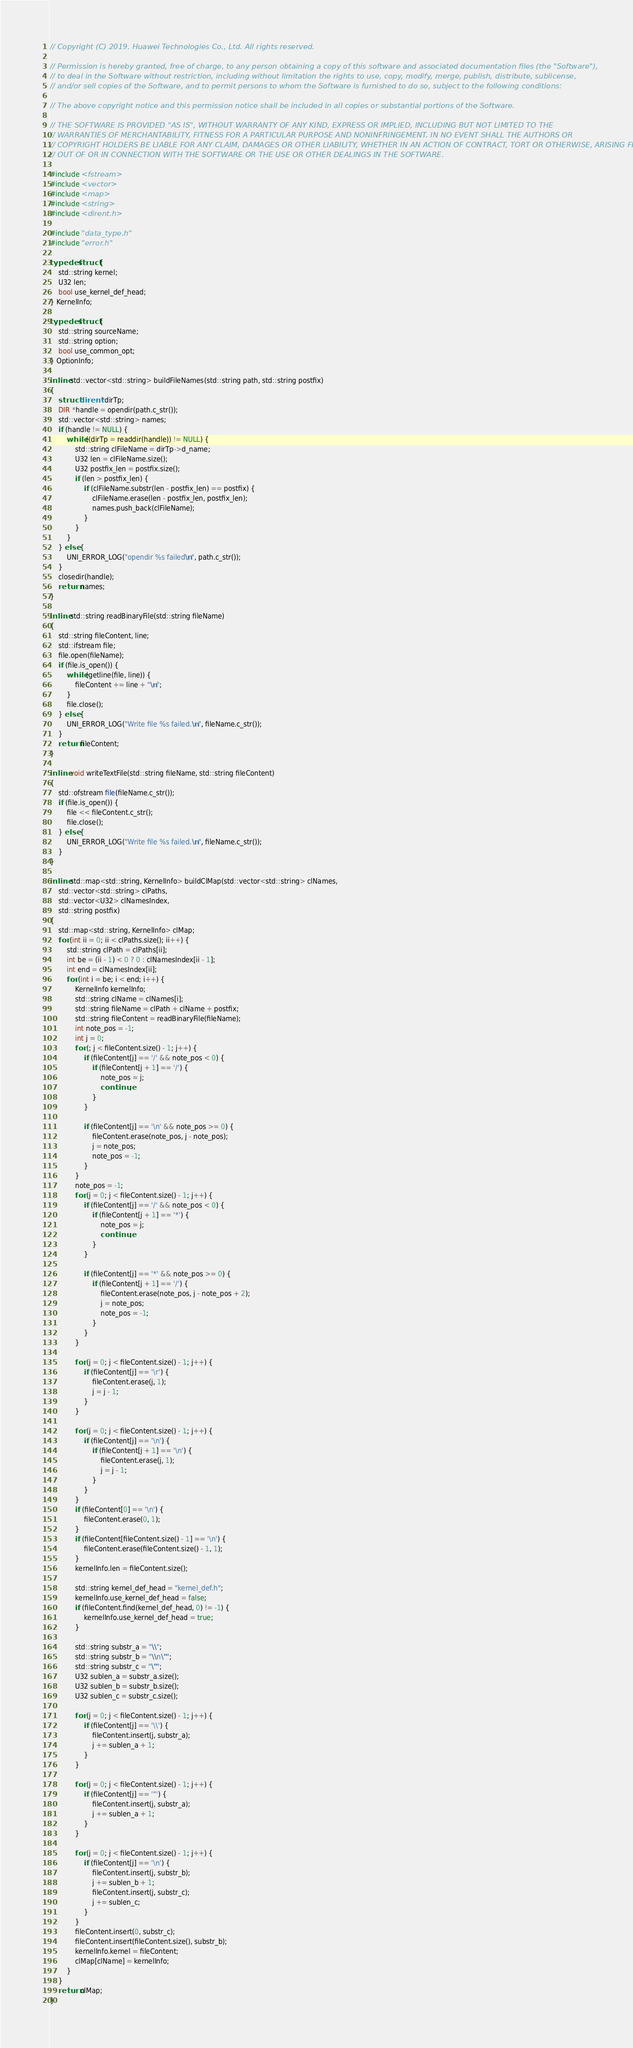<code> <loc_0><loc_0><loc_500><loc_500><_C++_>// Copyright (C) 2019. Huawei Technologies Co., Ltd. All rights reserved.

// Permission is hereby granted, free of charge, to any person obtaining a copy of this software and associated documentation files (the "Software"),
// to deal in the Software without restriction, including without limitation the rights to use, copy, modify, merge, publish, distribute, sublicense,
// and/or sell copies of the Software, and to permit persons to whom the Software is furnished to do so, subject to the following conditions:

// The above copyright notice and this permission notice shall be included in all copies or substantial portions of the Software.

// THE SOFTWARE IS PROVIDED "AS IS", WITHOUT WARRANTY OF ANY KIND, EXPRESS OR IMPLIED, INCLUDING BUT NOT LIMITED TO THE
// WARRANTIES OF MERCHANTABILITY, FITNESS FOR A PARTICULAR PURPOSE AND NONINFRINGEMENT. IN NO EVENT SHALL THE AUTHORS OR
// COPYRIGHT HOLDERS BE LIABLE FOR ANY CLAIM, DAMAGES OR OTHER LIABILITY, WHETHER IN AN ACTION OF CONTRACT, TORT OR OTHERWISE, ARISING FROM,
// OUT OF OR IN CONNECTION WITH THE SOFTWARE OR THE USE OR OTHER DEALINGS IN THE SOFTWARE.

#include <fstream>
#include <vector>
#include <map>
#include <string>
#include <dirent.h>

#include "data_type.h"
#include "error.h"

typedef struct {
    std::string kernel;
    U32 len;
    bool use_kernel_def_head;
} KernelInfo;

typedef struct {
    std::string sourceName;
    std::string option;
    bool use_common_opt;
} OptionInfo;

inline std::vector<std::string> buildFileNames(std::string path, std::string postfix)
{
    struct dirent *dirTp;
    DIR *handle = opendir(path.c_str());
    std::vector<std::string> names;
    if (handle != NULL) {
        while ((dirTp = readdir(handle)) != NULL) {
            std::string clFileName = dirTp->d_name;
            U32 len = clFileName.size();
            U32 postfix_len = postfix.size();
            if (len > postfix_len) {
                if (clFileName.substr(len - postfix_len) == postfix) {
                    clFileName.erase(len - postfix_len, postfix_len);
                    names.push_back(clFileName);
                }
            }
        }
    } else {
        UNI_ERROR_LOG("opendir %s failed\n", path.c_str());
    }
    closedir(handle);
    return names;
}

inline std::string readBinaryFile(std::string fileName)
{
    std::string fileContent, line;
    std::ifstream file;
    file.open(fileName);
    if (file.is_open()) {
        while (getline(file, line)) {
            fileContent += line + "\n";
        }
        file.close();
    } else {
        UNI_ERROR_LOG("Write file %s failed.\n", fileName.c_str());
    }
    return fileContent;
}

inline void writeTextFile(std::string fileName, std::string fileContent)
{
    std::ofstream file(fileName.c_str());
    if (file.is_open()) {
        file << fileContent.c_str();
        file.close();
    } else {
        UNI_ERROR_LOG("Write file %s failed.\n", fileName.c_str());
    }
}

inline std::map<std::string, KernelInfo> buildClMap(std::vector<std::string> clNames,
    std::vector<std::string> clPaths,
    std::vector<U32> clNamesIndex,
    std::string postfix)
{
    std::map<std::string, KernelInfo> clMap;
    for (int ii = 0; ii < clPaths.size(); ii++) {
        std::string clPath = clPaths[ii];
        int be = (ii - 1) < 0 ? 0 : clNamesIndex[ii - 1];
        int end = clNamesIndex[ii];
        for (int i = be; i < end; i++) {
            KernelInfo kernelInfo;
            std::string clName = clNames[i];
            std::string fileName = clPath + clName + postfix;
            std::string fileContent = readBinaryFile(fileName);
            int note_pos = -1;
            int j = 0;
            for (; j < fileContent.size() - 1; j++) {
                if (fileContent[j] == '/' && note_pos < 0) {
                    if (fileContent[j + 1] == '/') {
                        note_pos = j;
                        continue;
                    }
                }

                if (fileContent[j] == '\n' && note_pos >= 0) {
                    fileContent.erase(note_pos, j - note_pos);
                    j = note_pos;
                    note_pos = -1;
                }
            }
            note_pos = -1;
            for (j = 0; j < fileContent.size() - 1; j++) {
                if (fileContent[j] == '/' && note_pos < 0) {
                    if (fileContent[j + 1] == '*') {
                        note_pos = j;
                        continue;
                    }
                }

                if (fileContent[j] == '*' && note_pos >= 0) {
                    if (fileContent[j + 1] == '/') {
                        fileContent.erase(note_pos, j - note_pos + 2);
                        j = note_pos;
                        note_pos = -1;
                    }
                }
            }

            for (j = 0; j < fileContent.size() - 1; j++) {
                if (fileContent[j] == '\r') {
                    fileContent.erase(j, 1);
                    j = j - 1;
                }
            }

            for (j = 0; j < fileContent.size() - 1; j++) {
                if (fileContent[j] == '\n') {
                    if (fileContent[j + 1] == '\n') {
                        fileContent.erase(j, 1);
                        j = j - 1;
                    }
                }
            }
            if (fileContent[0] == '\n') {
                fileContent.erase(0, 1);
            }
            if (fileContent[fileContent.size() - 1] == '\n') {
                fileContent.erase(fileContent.size() - 1, 1);
            }
            kernelInfo.len = fileContent.size();

            std::string kernel_def_head = "kernel_def.h";
            kernelInfo.use_kernel_def_head = false;
            if (fileContent.find(kernel_def_head, 0) != -1) {
                kernelInfo.use_kernel_def_head = true;
            }

            std::string substr_a = "\\";
            std::string substr_b = "\\n\"";
            std::string substr_c = "\"";
            U32 sublen_a = substr_a.size();
            U32 sublen_b = substr_b.size();
            U32 sublen_c = substr_c.size();

            for (j = 0; j < fileContent.size() - 1; j++) {
                if (fileContent[j] == '\\') {
                    fileContent.insert(j, substr_a);
                    j += sublen_a + 1;
                }
            }

            for (j = 0; j < fileContent.size() - 1; j++) {
                if (fileContent[j] == '"') {
                    fileContent.insert(j, substr_a);
                    j += sublen_a + 1;
                }
            }

            for (j = 0; j < fileContent.size() - 1; j++) {
                if (fileContent[j] == '\n') {
                    fileContent.insert(j, substr_b);
                    j += sublen_b + 1;
                    fileContent.insert(j, substr_c);
                    j += sublen_c;
                }
            }
            fileContent.insert(0, substr_c);
            fileContent.insert(fileContent.size(), substr_b);
            kernelInfo.kernel = fileContent;
            clMap[clName] = kernelInfo;
        }
    }
    return clMap;
}
</code> 